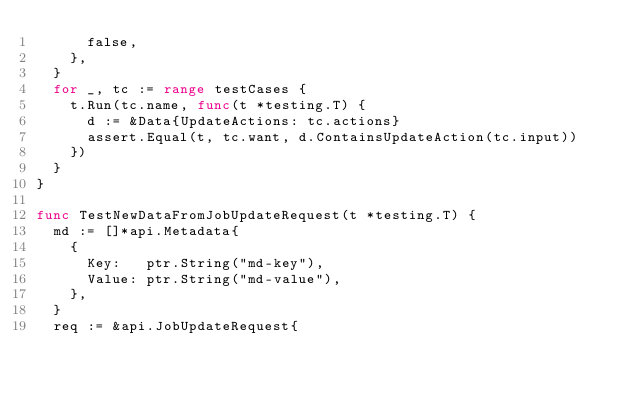Convert code to text. <code><loc_0><loc_0><loc_500><loc_500><_Go_>			false,
		},
	}
	for _, tc := range testCases {
		t.Run(tc.name, func(t *testing.T) {
			d := &Data{UpdateActions: tc.actions}
			assert.Equal(t, tc.want, d.ContainsUpdateAction(tc.input))
		})
	}
}

func TestNewDataFromJobUpdateRequest(t *testing.T) {
	md := []*api.Metadata{
		{
			Key:   ptr.String("md-key"),
			Value: ptr.String("md-value"),
		},
	}
	req := &api.JobUpdateRequest{</code> 